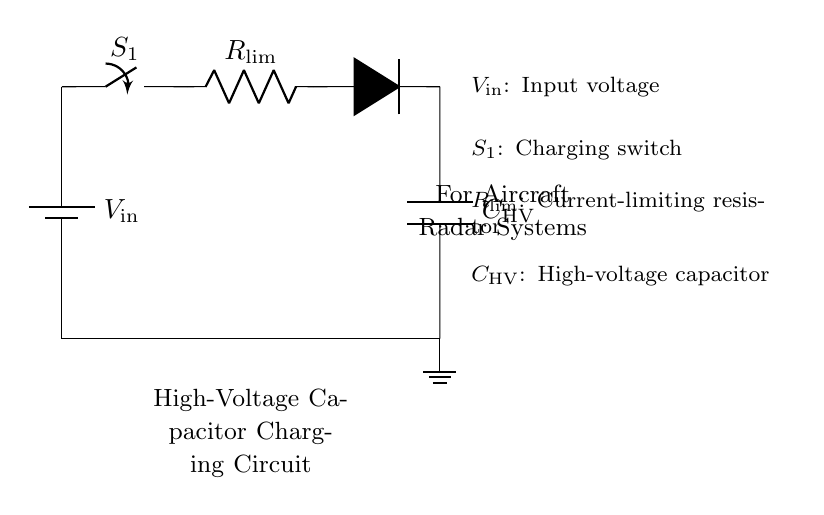What is the input voltage in this circuit? The input voltage is labeled as V in the circuit diagram. It provides the power necessary for charging the high-voltage capacitor.
Answer: V in What is the role of the switch labeled S1? The switch S1 allows or interrupts the flow of current in the circuit. When closed, it enables the charging process for the capacitor; when open, it stops the charging.
Answer: Charging switch Who limits the current in this charging circuit? The current is limited by the resistor labeled R lim. This component is specifically included to prevent excessive current from damaging the capacitor or the circuit components.
Answer: R lim What type of capacitor is used in this circuit? The circuit uses a high-voltage capacitor, which is specified as C HV. This type of capacitor is designed to handle high voltages, such as those found in radar systems.
Answer: High-voltage capacitor How does the diode affect the capacitor charging? The diode allows current to flow in one direction, which helps charge the capacitor while preventing it from discharging back into the circuit when the input voltage is removed.
Answer: Prevents reverse current What happens if the current-limiting resistor is bypassed? Bypassing the current-limiting resistor may cause excessive current to flow into the capacitor, risking damage to both the capacitor and the power supply due to high inrush current.
Answer: Overheating and damage risk What is the purpose of this charging circuit in aircraft radar systems? This circuit charges a high-voltage capacitor required for powering radar systems in aircraft, ensuring quick discharge for pulse generation while protecting the overall circuit.
Answer: Capacitor charging for radar 